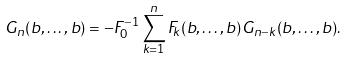<formula> <loc_0><loc_0><loc_500><loc_500>G _ { n } ( b , \dots , b ) = - F _ { 0 } ^ { - 1 } \sum _ { k = 1 } ^ { n } F _ { k } ( b , \dots , b ) G _ { n - k } ( b , \dots , b ) .</formula> 